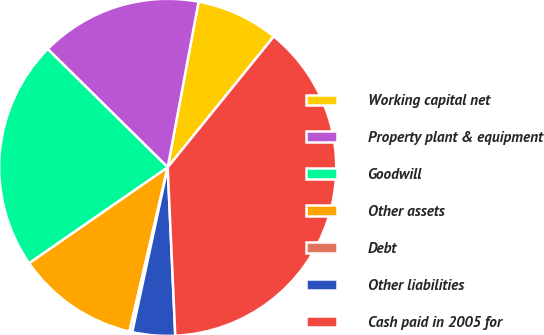<chart> <loc_0><loc_0><loc_500><loc_500><pie_chart><fcel>Working capital net<fcel>Property plant & equipment<fcel>Goodwill<fcel>Other assets<fcel>Debt<fcel>Other liabilities<fcel>Cash paid in 2005 for<nl><fcel>7.91%<fcel>15.54%<fcel>22.02%<fcel>11.72%<fcel>0.27%<fcel>4.09%<fcel>38.44%<nl></chart> 